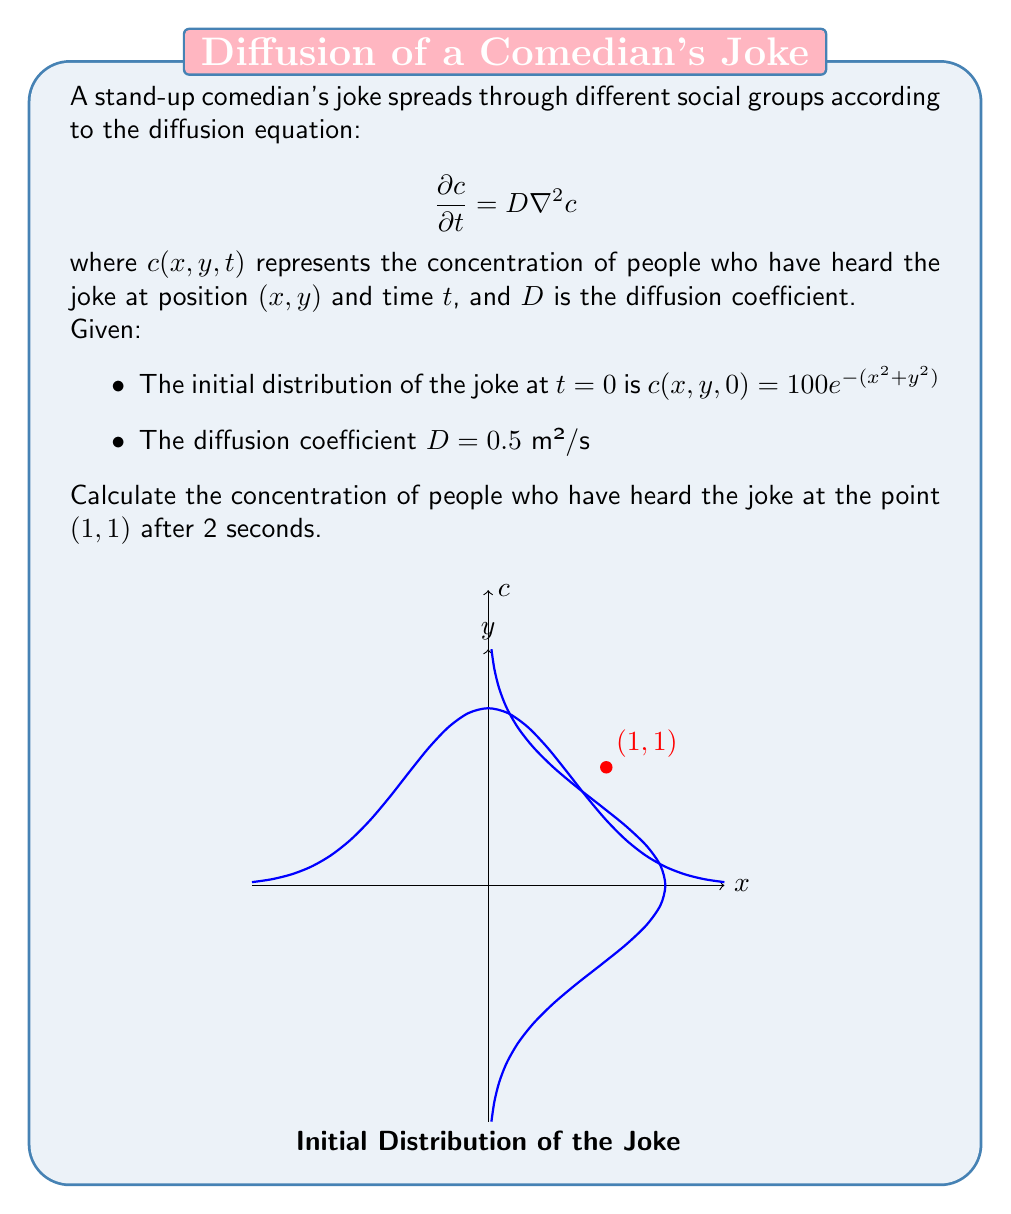Could you help me with this problem? To solve this problem, we'll use the solution to the 2D diffusion equation for an initial Gaussian distribution:

$$c(x,y,t) = \frac{M}{4\pi Dt + \sigma^2} \exp\left(-\frac{x^2+y^2}{4Dt + \sigma^2}\right)$$

where $M$ is the total amount of the substance and $\sigma^2$ is related to the initial spread.

Step 1: Identify the parameters from the initial condition.
$c(x,y,0) = 100e^{-(x^2+y^2)}$
Comparing this with the general form $Me^{-(x^2+y^2)/\sigma^2}$, we get:
$M = 100\pi$ and $\sigma^2 = 1$

Step 2: Substitute the known values into the solution equation.
$D = 0.5$ m²/s
$t = 2$ s
$x = 1$, $y = 1$

$$c(1,1,2) = \frac{100\pi}{4\pi(0.5)(2) + 1} \exp\left(-\frac{1^2+1^2}{4(0.5)(2) + 1}\right)$$

Step 3: Simplify the expression.
$$c(1,1,2) = \frac{100\pi}{4\pi + 1} \exp\left(-\frac{2}{3}\right)$$

Step 4: Calculate the final result.
$$c(1,1,2) \approx 14.49$$
Answer: $14.49$ people/m² 